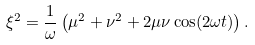<formula> <loc_0><loc_0><loc_500><loc_500>\xi ^ { 2 } = \frac { 1 } { \omega } \left ( \mu ^ { 2 } + \nu ^ { 2 } + 2 \mu \nu \cos ( 2 \omega t ) \right ) .</formula> 